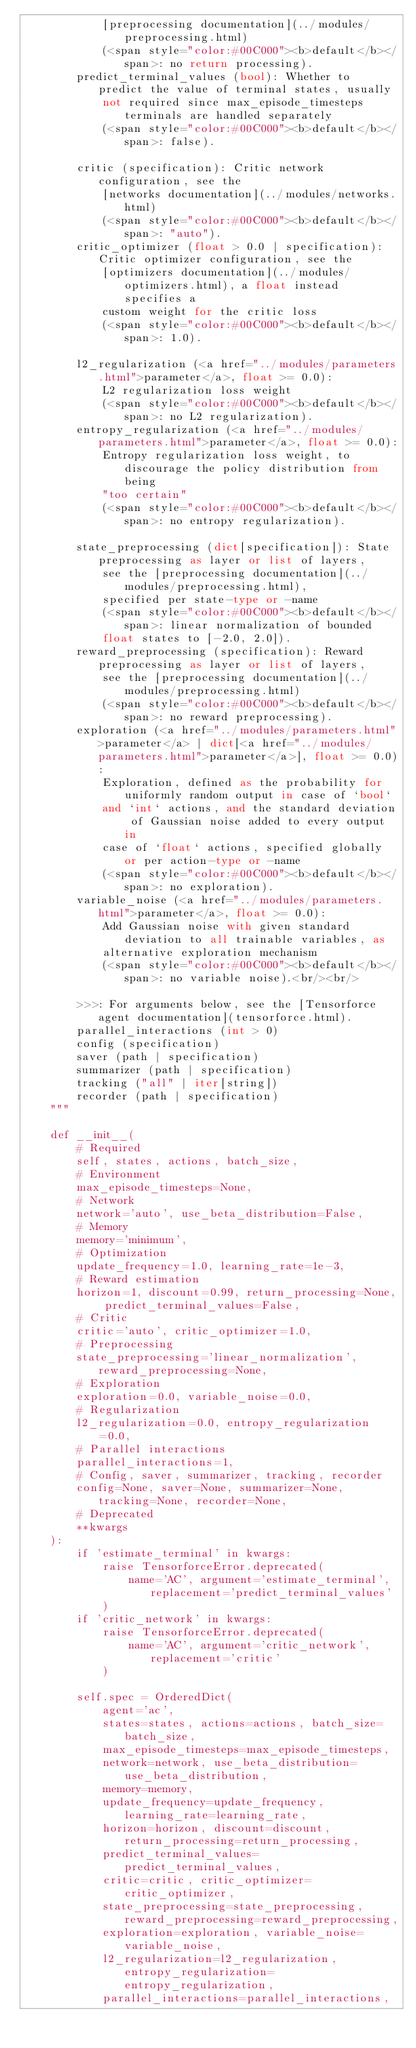Convert code to text. <code><loc_0><loc_0><loc_500><loc_500><_Python_>            [preprocessing documentation](../modules/preprocessing.html)
            (<span style="color:#00C000"><b>default</b></span>: no return processing).
        predict_terminal_values (bool): Whether to predict the value of terminal states, usually
            not required since max_episode_timesteps terminals are handled separately
            (<span style="color:#00C000"><b>default</b></span>: false).

        critic (specification): Critic network configuration, see the
            [networks documentation](../modules/networks.html)
            (<span style="color:#00C000"><b>default</b></span>: "auto").
        critic_optimizer (float > 0.0 | specification): Critic optimizer configuration, see the
            [optimizers documentation](../modules/optimizers.html), a float instead specifies a
            custom weight for the critic loss
            (<span style="color:#00C000"><b>default</b></span>: 1.0).

        l2_regularization (<a href="../modules/parameters.html">parameter</a>, float >= 0.0):
            L2 regularization loss weight
            (<span style="color:#00C000"><b>default</b></span>: no L2 regularization).
        entropy_regularization (<a href="../modules/parameters.html">parameter</a>, float >= 0.0):
            Entropy regularization loss weight, to discourage the policy distribution from being
            "too certain"
            (<span style="color:#00C000"><b>default</b></span>: no entropy regularization).

        state_preprocessing (dict[specification]): State preprocessing as layer or list of layers,
            see the [preprocessing documentation](../modules/preprocessing.html),
            specified per state-type or -name
            (<span style="color:#00C000"><b>default</b></span>: linear normalization of bounded
            float states to [-2.0, 2.0]).
        reward_preprocessing (specification): Reward preprocessing as layer or list of layers,
            see the [preprocessing documentation](../modules/preprocessing.html)
            (<span style="color:#00C000"><b>default</b></span>: no reward preprocessing).
        exploration (<a href="../modules/parameters.html">parameter</a> | dict[<a href="../modules/parameters.html">parameter</a>], float >= 0.0):
            Exploration, defined as the probability for uniformly random output in case of `bool`
            and `int` actions, and the standard deviation of Gaussian noise added to every output in
            case of `float` actions, specified globally or per action-type or -name
            (<span style="color:#00C000"><b>default</b></span>: no exploration).
        variable_noise (<a href="../modules/parameters.html">parameter</a>, float >= 0.0):
            Add Gaussian noise with given standard deviation to all trainable variables, as
            alternative exploration mechanism
            (<span style="color:#00C000"><b>default</b></span>: no variable noise).<br/><br/>

        >>>: For arguments below, see the [Tensorforce agent documentation](tensorforce.html).
        parallel_interactions (int > 0)
        config (specification)
        saver (path | specification)
        summarizer (path | specification)
        tracking ("all" | iter[string])
        recorder (path | specification)
    """

    def __init__(
        # Required
        self, states, actions, batch_size,
        # Environment
        max_episode_timesteps=None,
        # Network
        network='auto', use_beta_distribution=False,
        # Memory
        memory='minimum',
        # Optimization
        update_frequency=1.0, learning_rate=1e-3,
        # Reward estimation
        horizon=1, discount=0.99, return_processing=None, predict_terminal_values=False,
        # Critic
        critic='auto', critic_optimizer=1.0,
        # Preprocessing
        state_preprocessing='linear_normalization', reward_preprocessing=None,
        # Exploration
        exploration=0.0, variable_noise=0.0,
        # Regularization
        l2_regularization=0.0, entropy_regularization=0.0,
        # Parallel interactions
        parallel_interactions=1,
        # Config, saver, summarizer, tracking, recorder
        config=None, saver=None, summarizer=None, tracking=None, recorder=None,
        # Deprecated
        **kwargs
    ):
        if 'estimate_terminal' in kwargs:
            raise TensorforceError.deprecated(
                name='AC', argument='estimate_terminal', replacement='predict_terminal_values'
            )
        if 'critic_network' in kwargs:
            raise TensorforceError.deprecated(
                name='AC', argument='critic_network', replacement='critic'
            )

        self.spec = OrderedDict(
            agent='ac',
            states=states, actions=actions, batch_size=batch_size,
            max_episode_timesteps=max_episode_timesteps,
            network=network, use_beta_distribution=use_beta_distribution,
            memory=memory,
            update_frequency=update_frequency, learning_rate=learning_rate,
            horizon=horizon, discount=discount, return_processing=return_processing,
            predict_terminal_values=predict_terminal_values,
            critic=critic, critic_optimizer=critic_optimizer,
            state_preprocessing=state_preprocessing, reward_preprocessing=reward_preprocessing,
            exploration=exploration, variable_noise=variable_noise,
            l2_regularization=l2_regularization, entropy_regularization=entropy_regularization,
            parallel_interactions=parallel_interactions,</code> 